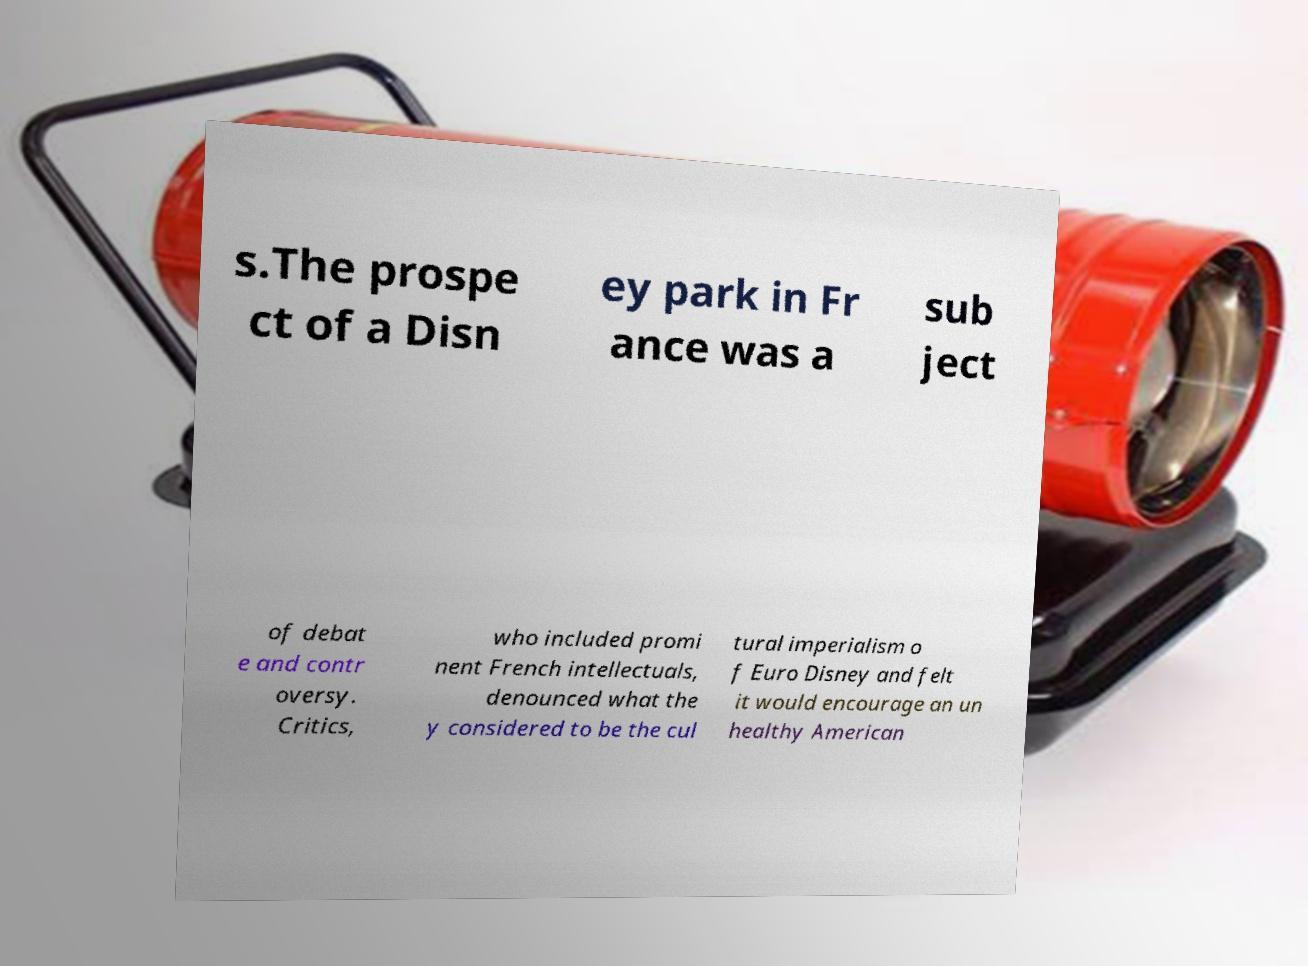There's text embedded in this image that I need extracted. Can you transcribe it verbatim? s.The prospe ct of a Disn ey park in Fr ance was a sub ject of debat e and contr oversy. Critics, who included promi nent French intellectuals, denounced what the y considered to be the cul tural imperialism o f Euro Disney and felt it would encourage an un healthy American 